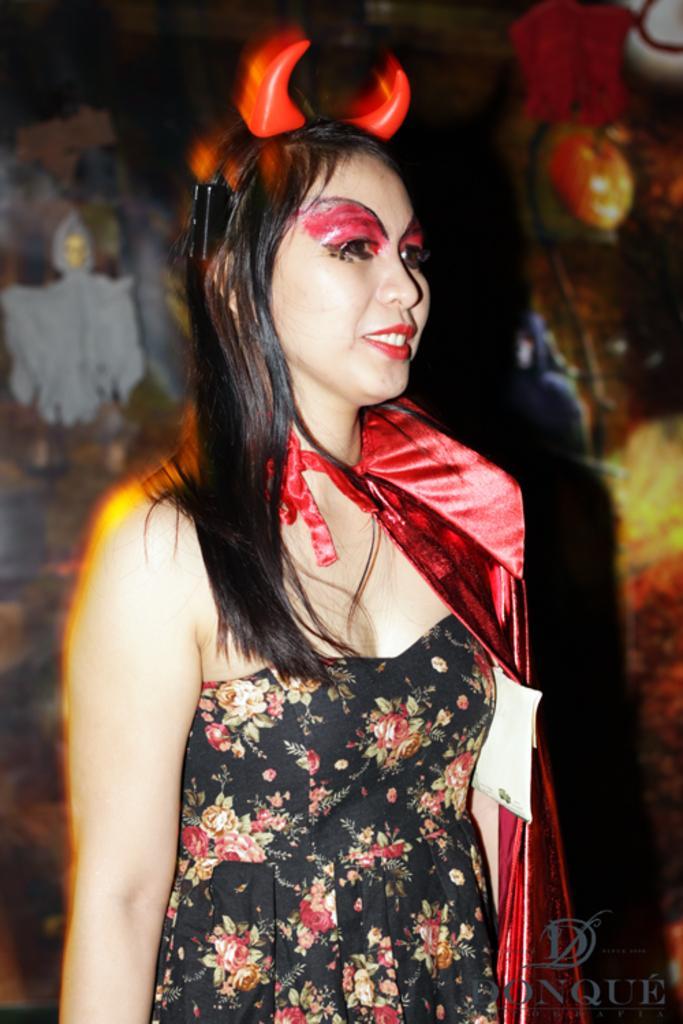In one or two sentences, can you explain what this image depicts? In this picture we can see a woman is standing and smiling, she is wearing devil horns on her head, at the right bottom there is some text. 